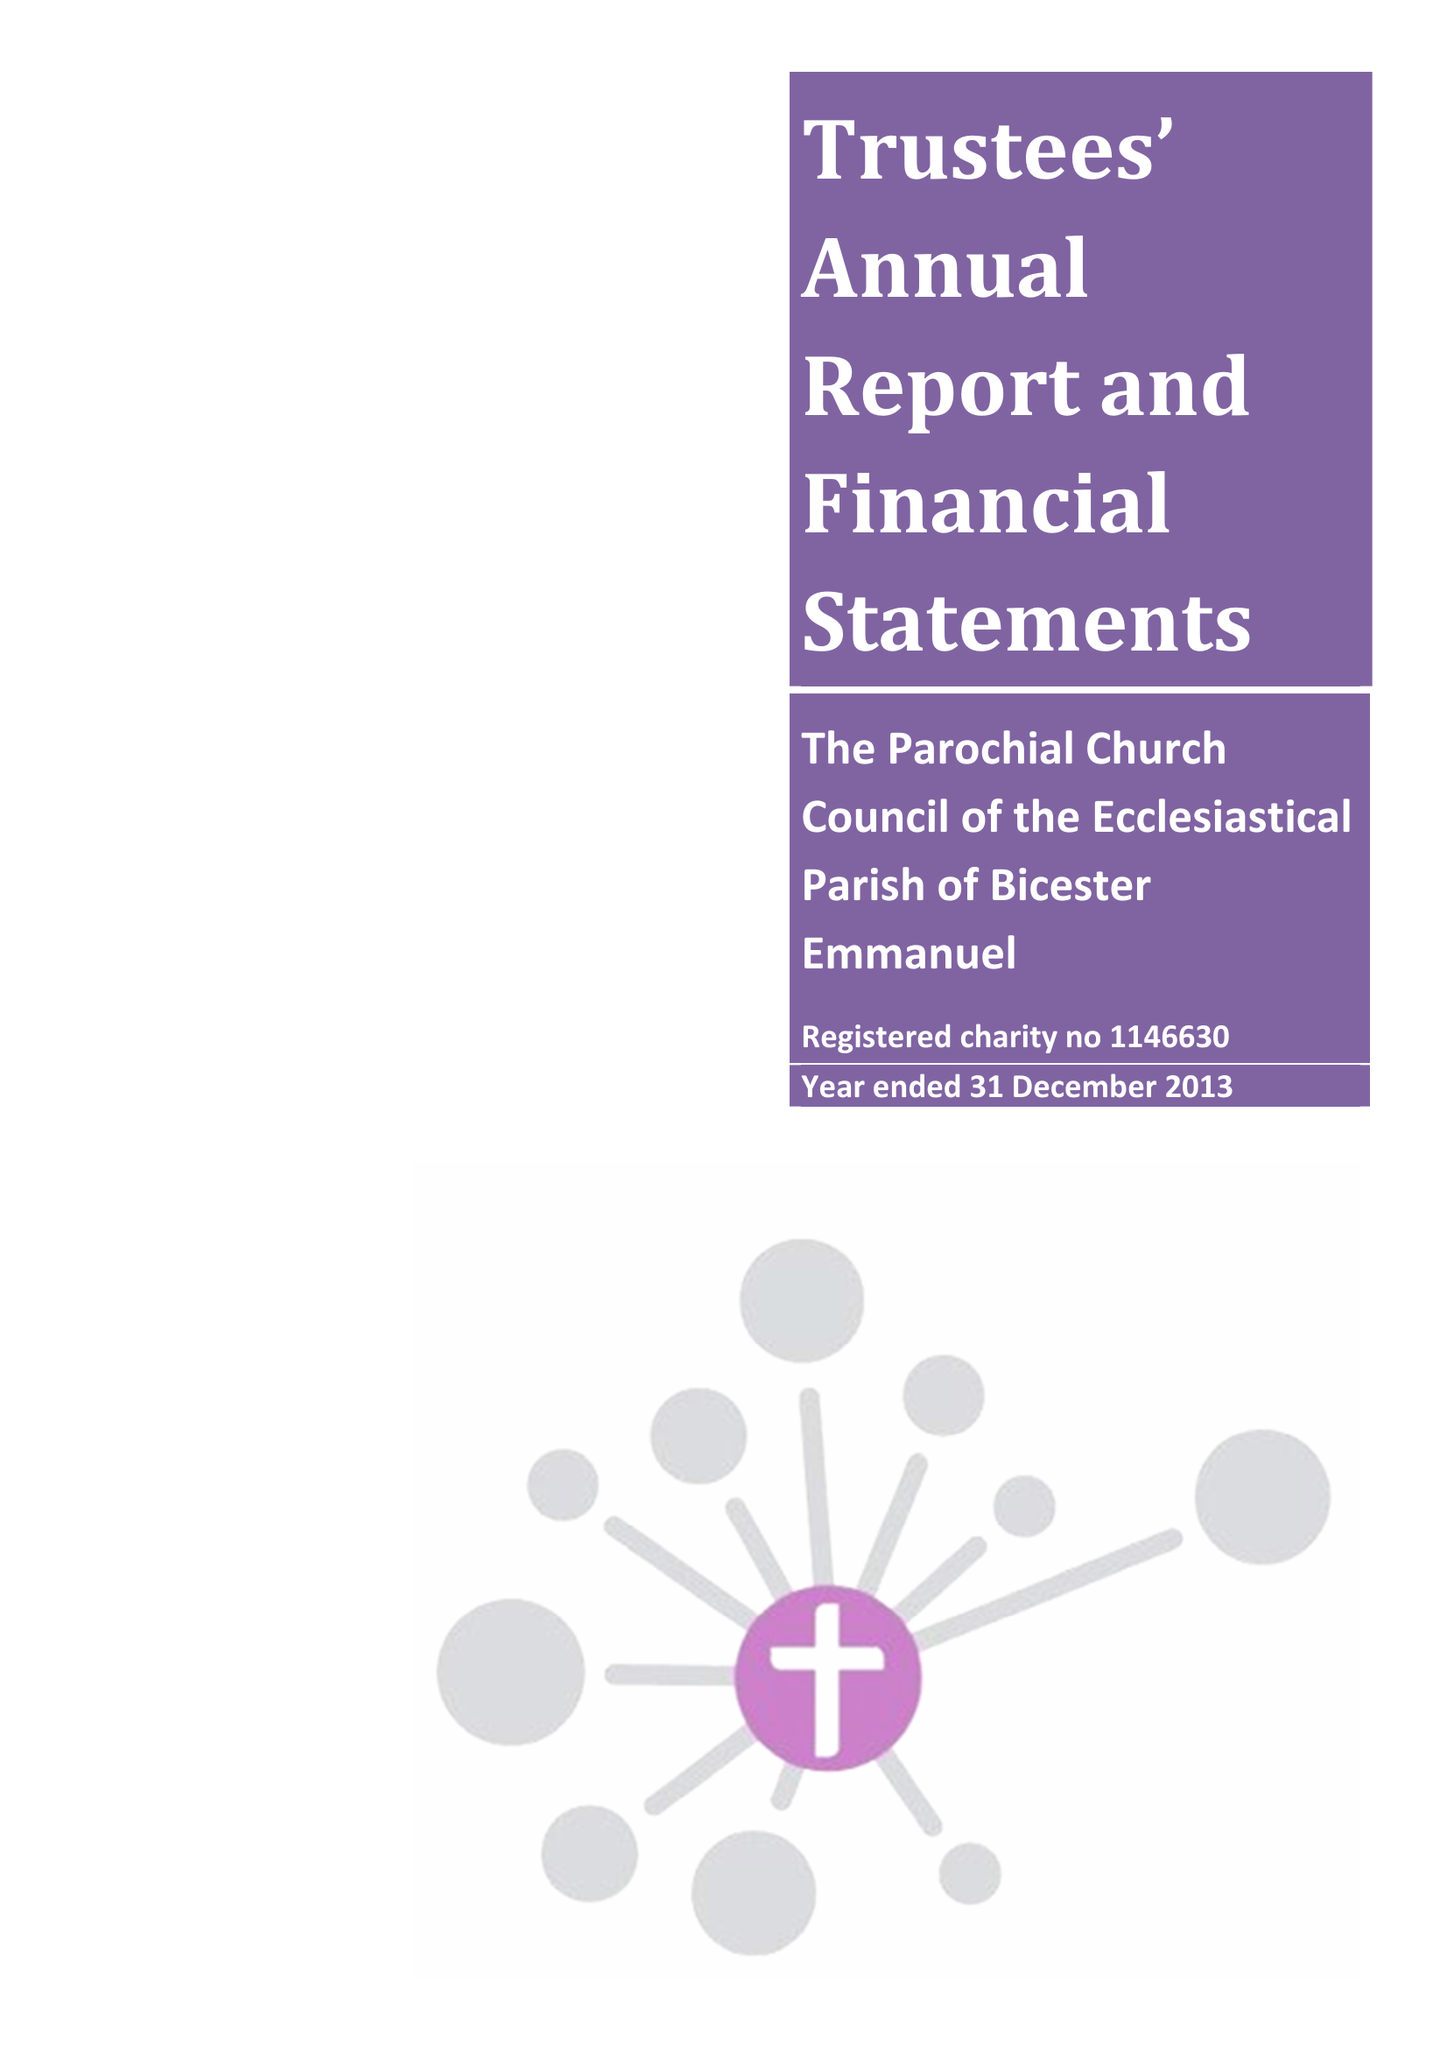What is the value for the spending_annually_in_british_pounds?
Answer the question using a single word or phrase. 159190.00 